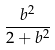<formula> <loc_0><loc_0><loc_500><loc_500>\frac { b ^ { 2 } } { 2 + b ^ { 2 } }</formula> 